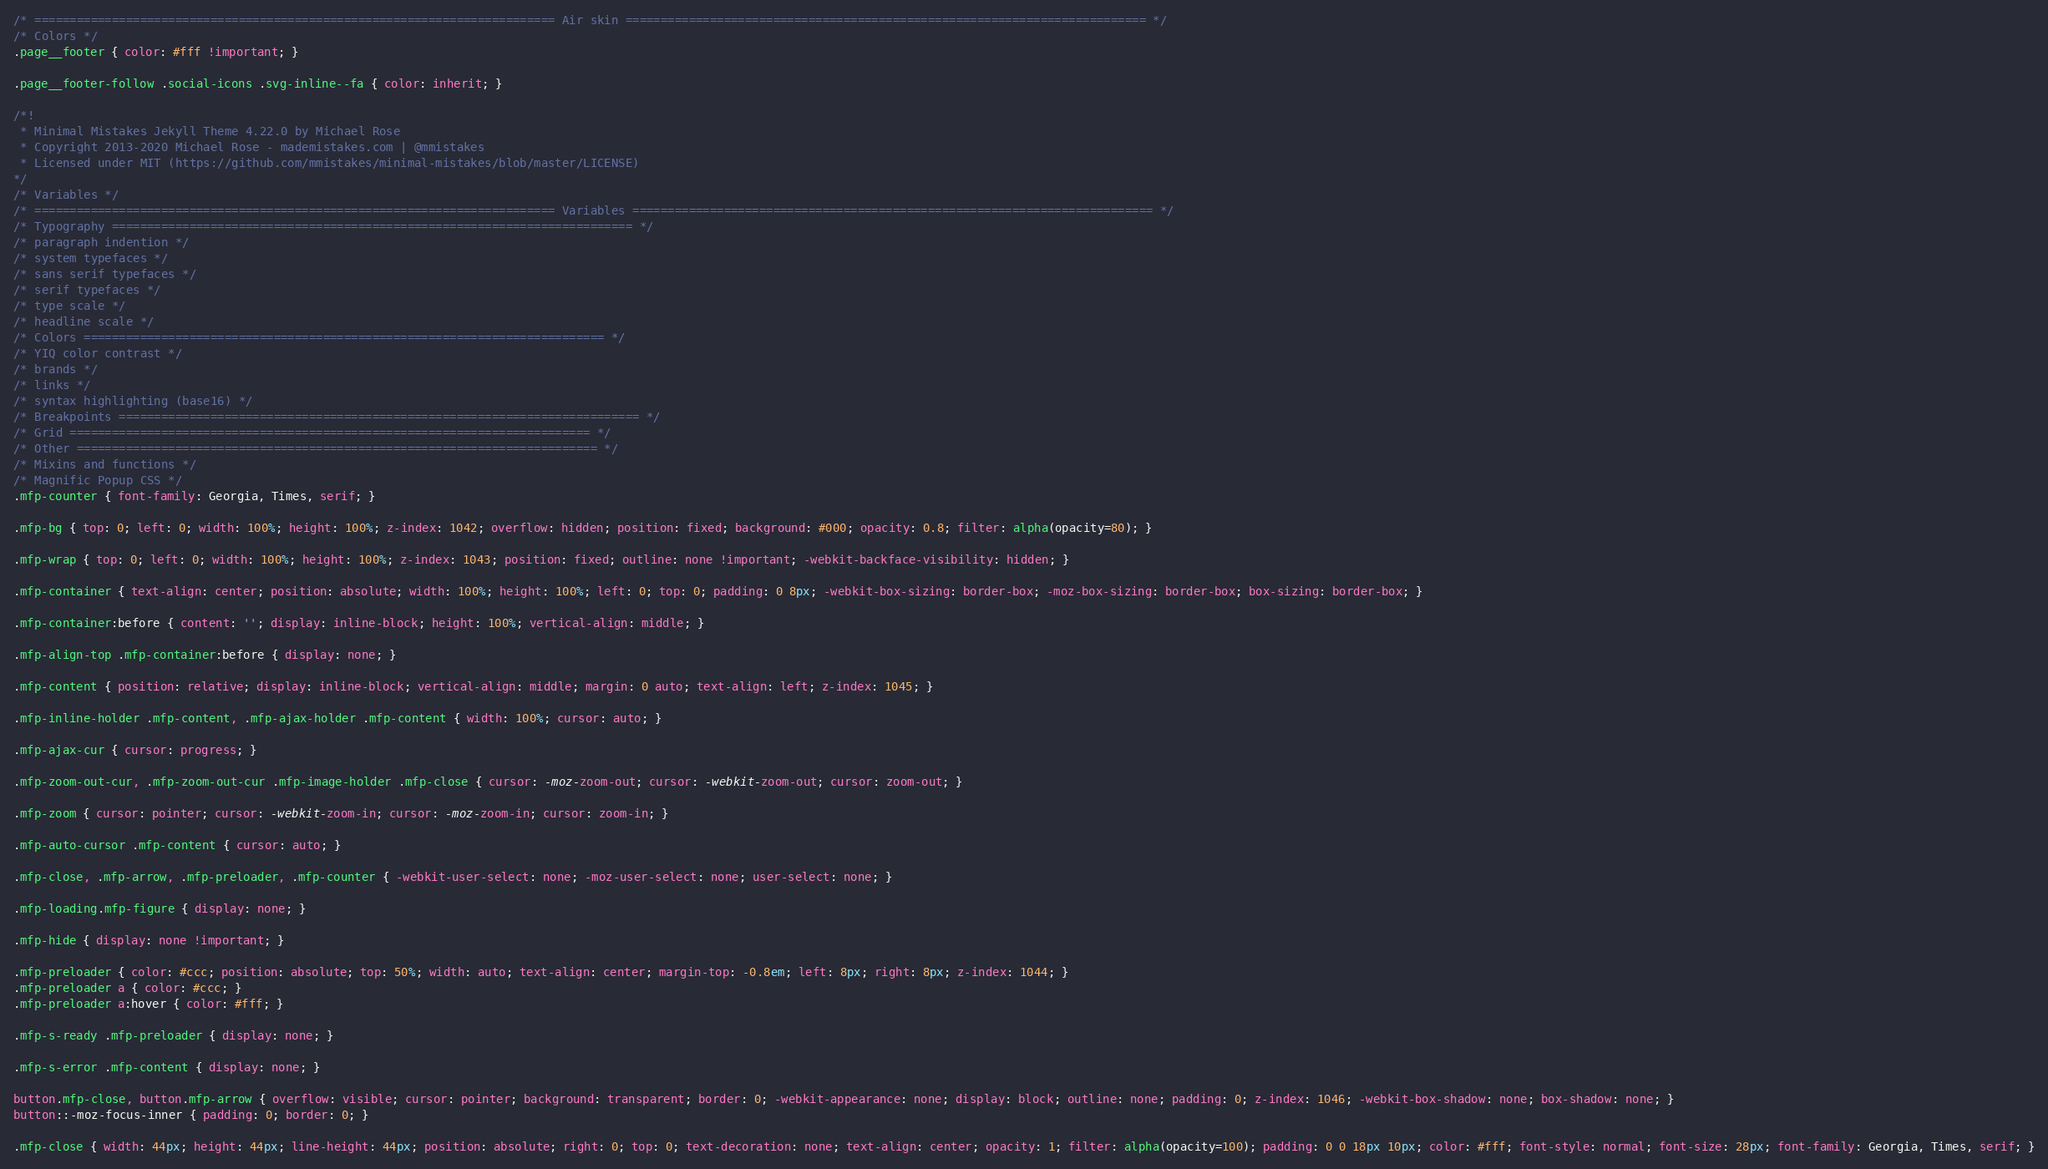<code> <loc_0><loc_0><loc_500><loc_500><_CSS_>/* ========================================================================== Air skin ========================================================================== */
/* Colors */
.page__footer { color: #fff !important; }

.page__footer-follow .social-icons .svg-inline--fa { color: inherit; }

/*!
 * Minimal Mistakes Jekyll Theme 4.22.0 by Michael Rose
 * Copyright 2013-2020 Michael Rose - mademistakes.com | @mmistakes
 * Licensed under MIT (https://github.com/mmistakes/minimal-mistakes/blob/master/LICENSE)
*/
/* Variables */
/* ========================================================================== Variables ========================================================================== */
/* Typography ========================================================================== */
/* paragraph indention */
/* system typefaces */
/* sans serif typefaces */
/* serif typefaces */
/* type scale */
/* headline scale */
/* Colors ========================================================================== */
/* YIQ color contrast */
/* brands */
/* links */
/* syntax highlighting (base16) */
/* Breakpoints ========================================================================== */
/* Grid ========================================================================== */
/* Other ========================================================================== */
/* Mixins and functions */
/* Magnific Popup CSS */
.mfp-counter { font-family: Georgia, Times, serif; }

.mfp-bg { top: 0; left: 0; width: 100%; height: 100%; z-index: 1042; overflow: hidden; position: fixed; background: #000; opacity: 0.8; filter: alpha(opacity=80); }

.mfp-wrap { top: 0; left: 0; width: 100%; height: 100%; z-index: 1043; position: fixed; outline: none !important; -webkit-backface-visibility: hidden; }

.mfp-container { text-align: center; position: absolute; width: 100%; height: 100%; left: 0; top: 0; padding: 0 8px; -webkit-box-sizing: border-box; -moz-box-sizing: border-box; box-sizing: border-box; }

.mfp-container:before { content: ''; display: inline-block; height: 100%; vertical-align: middle; }

.mfp-align-top .mfp-container:before { display: none; }

.mfp-content { position: relative; display: inline-block; vertical-align: middle; margin: 0 auto; text-align: left; z-index: 1045; }

.mfp-inline-holder .mfp-content, .mfp-ajax-holder .mfp-content { width: 100%; cursor: auto; }

.mfp-ajax-cur { cursor: progress; }

.mfp-zoom-out-cur, .mfp-zoom-out-cur .mfp-image-holder .mfp-close { cursor: -moz-zoom-out; cursor: -webkit-zoom-out; cursor: zoom-out; }

.mfp-zoom { cursor: pointer; cursor: -webkit-zoom-in; cursor: -moz-zoom-in; cursor: zoom-in; }

.mfp-auto-cursor .mfp-content { cursor: auto; }

.mfp-close, .mfp-arrow, .mfp-preloader, .mfp-counter { -webkit-user-select: none; -moz-user-select: none; user-select: none; }

.mfp-loading.mfp-figure { display: none; }

.mfp-hide { display: none !important; }

.mfp-preloader { color: #ccc; position: absolute; top: 50%; width: auto; text-align: center; margin-top: -0.8em; left: 8px; right: 8px; z-index: 1044; }
.mfp-preloader a { color: #ccc; }
.mfp-preloader a:hover { color: #fff; }

.mfp-s-ready .mfp-preloader { display: none; }

.mfp-s-error .mfp-content { display: none; }

button.mfp-close, button.mfp-arrow { overflow: visible; cursor: pointer; background: transparent; border: 0; -webkit-appearance: none; display: block; outline: none; padding: 0; z-index: 1046; -webkit-box-shadow: none; box-shadow: none; }
button::-moz-focus-inner { padding: 0; border: 0; }

.mfp-close { width: 44px; height: 44px; line-height: 44px; position: absolute; right: 0; top: 0; text-decoration: none; text-align: center; opacity: 1; filter: alpha(opacity=100); padding: 0 0 18px 10px; color: #fff; font-style: normal; font-size: 28px; font-family: Georgia, Times, serif; }</code> 